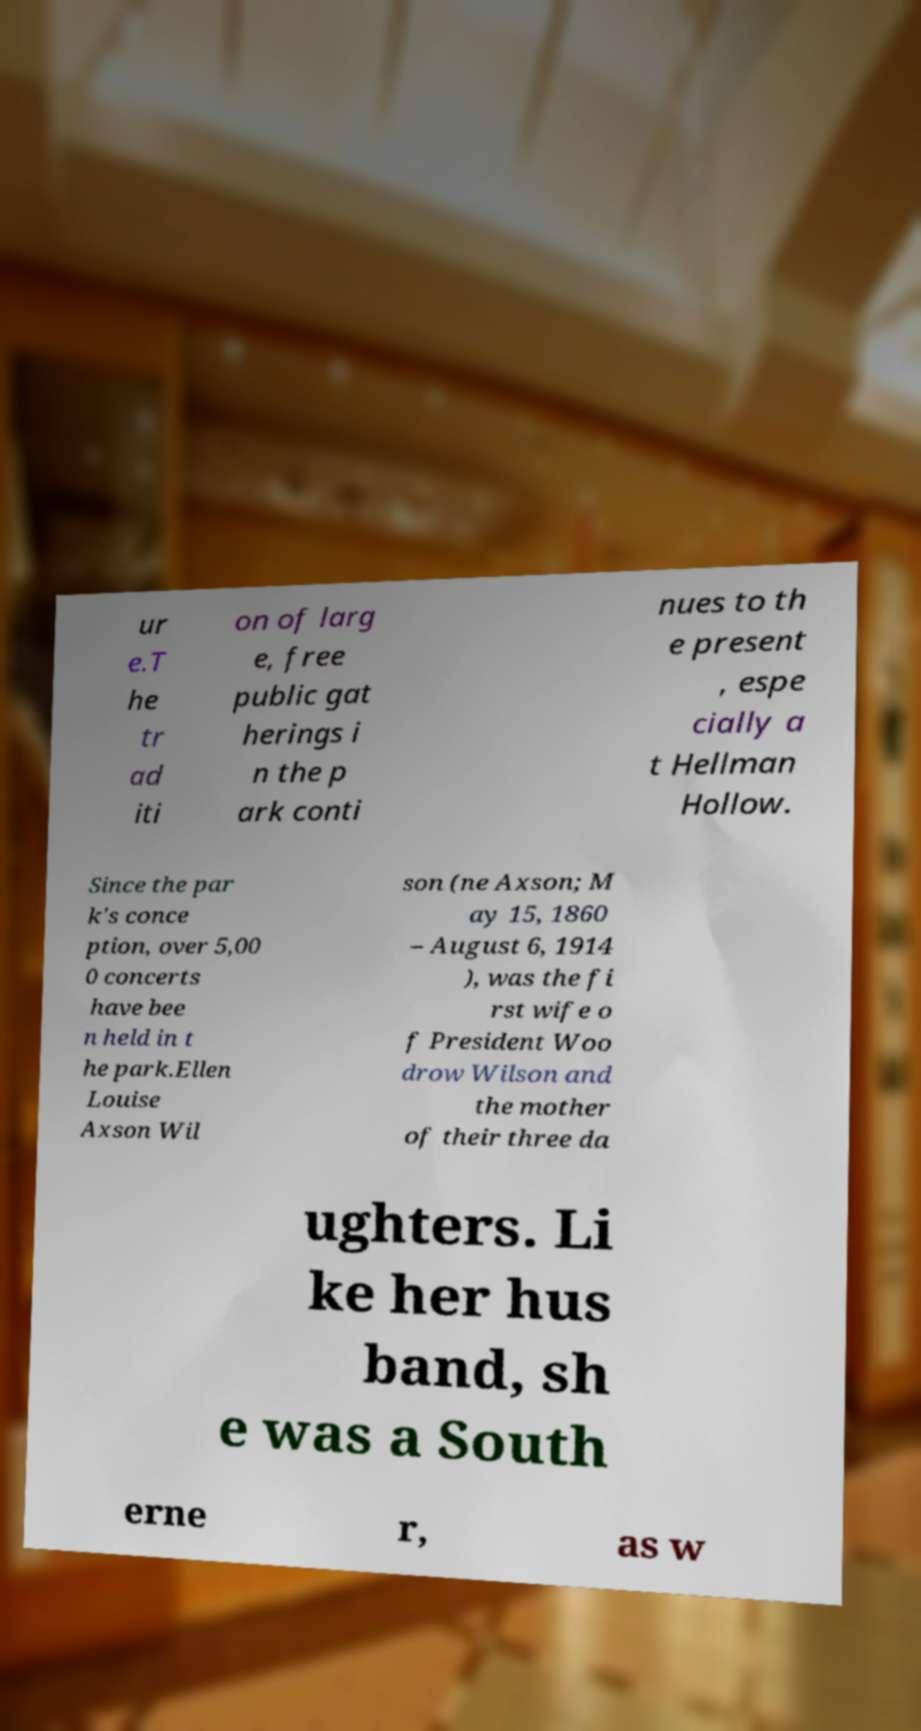What messages or text are displayed in this image? I need them in a readable, typed format. ur e.T he tr ad iti on of larg e, free public gat herings i n the p ark conti nues to th e present , espe cially a t Hellman Hollow. Since the par k's conce ption, over 5,00 0 concerts have bee n held in t he park.Ellen Louise Axson Wil son (ne Axson; M ay 15, 1860 – August 6, 1914 ), was the fi rst wife o f President Woo drow Wilson and the mother of their three da ughters. Li ke her hus band, sh e was a South erne r, as w 